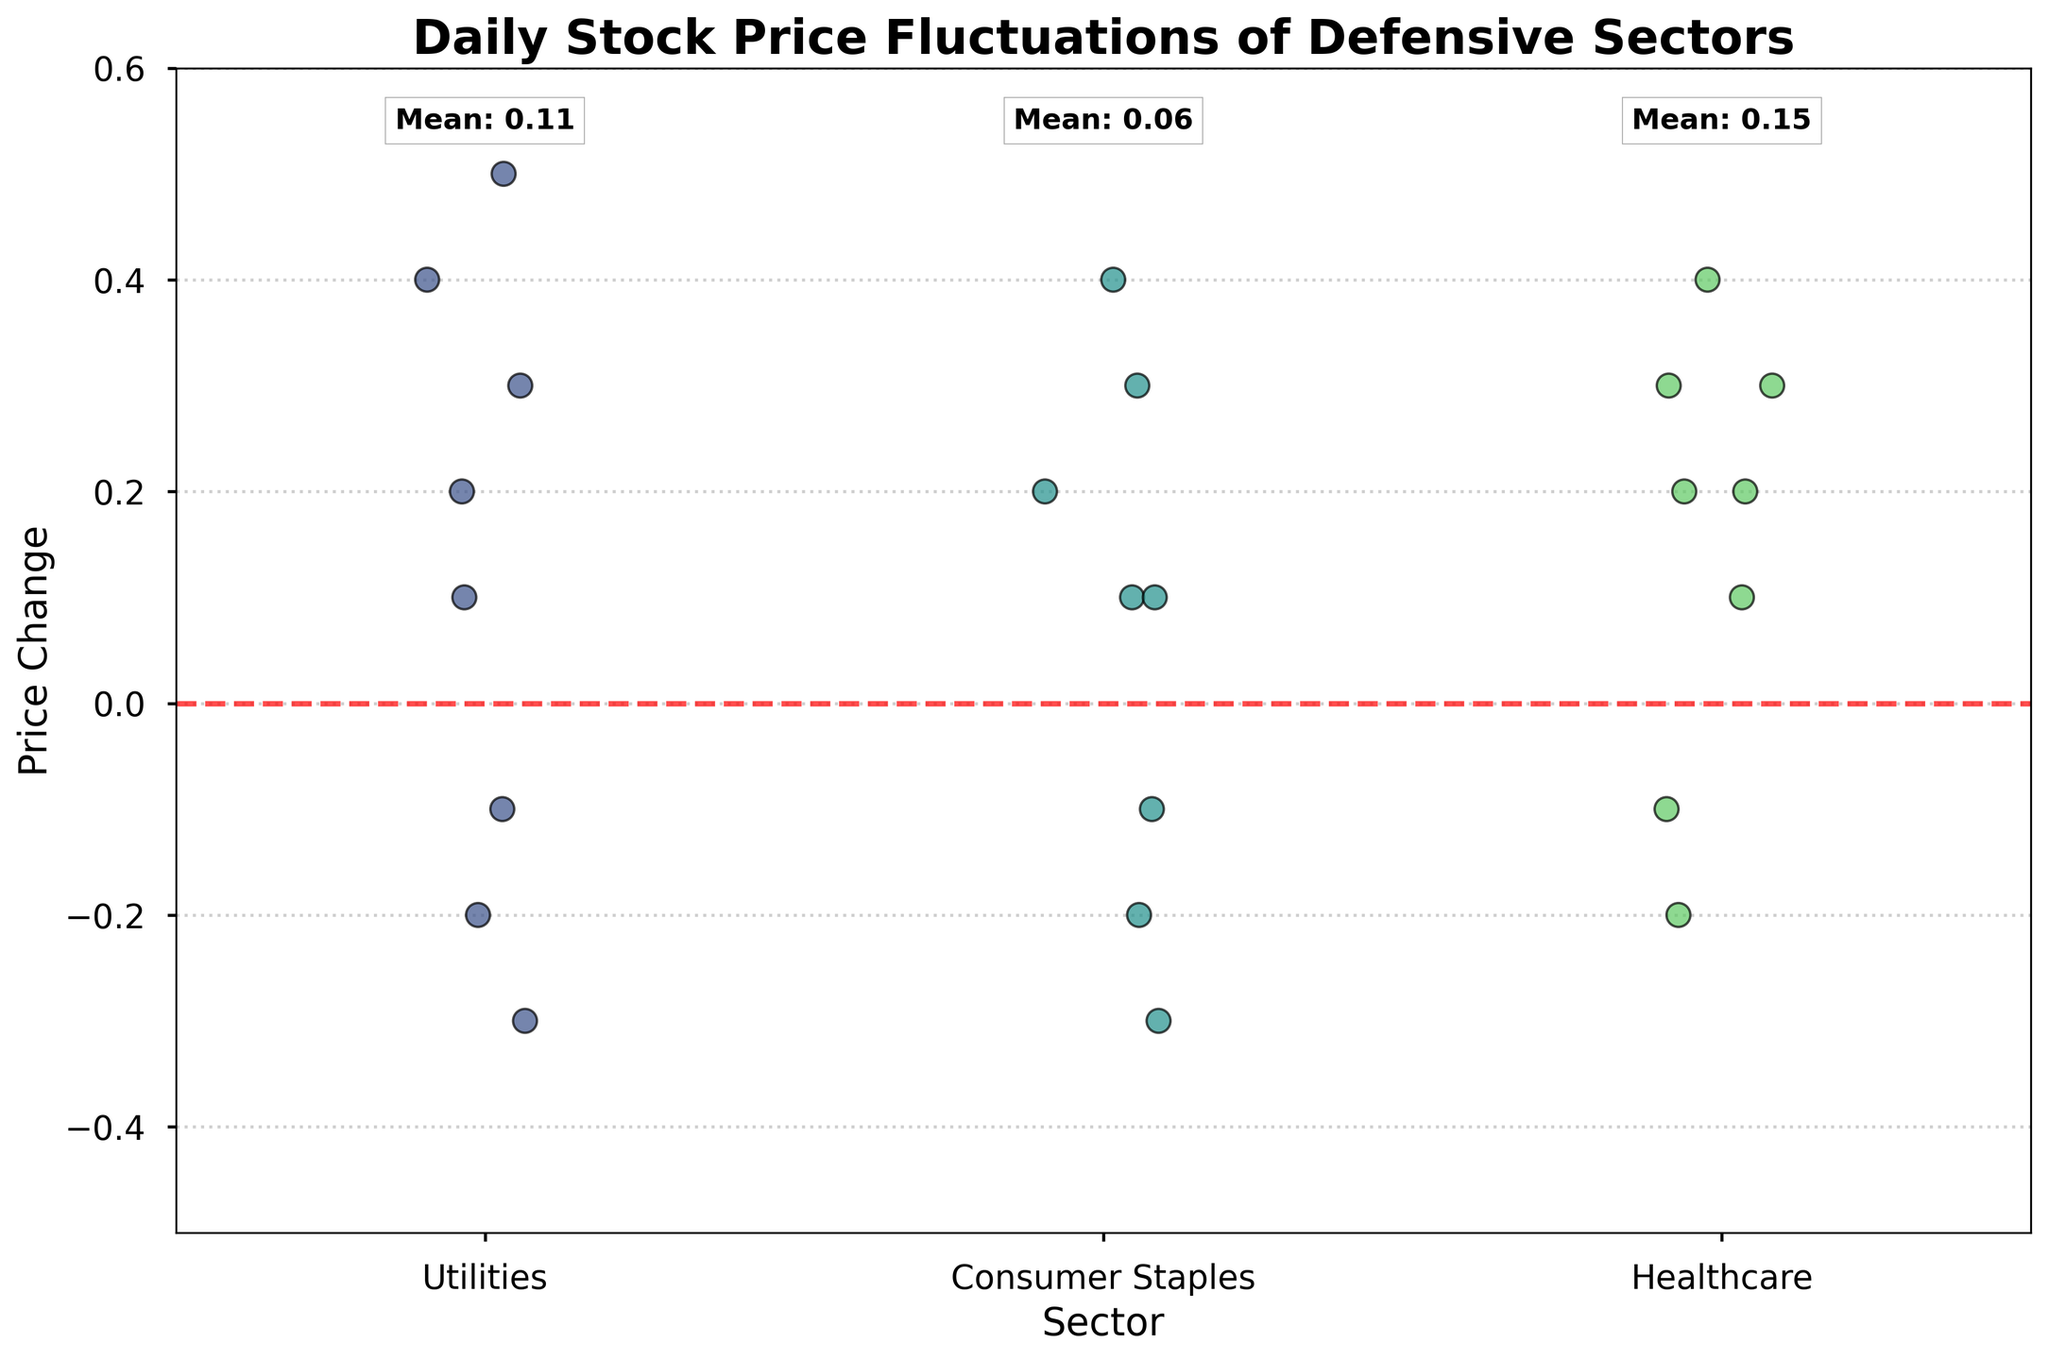What is the title of the figure? The title of the figure appears at the top in bold text. It states the topic or theme of the visualization.
Answer: Daily Stock Price Fluctuations of Defensive Sectors Which sector shows the highest mean price change? The memory aid text box near the top of each sector shows the mean price change. The sector with the highest value in this box has the highest mean price change.
Answer: Healthcare How does the Utilities sector's mean price change compare to the Consumer Staples sector? Examine the mean change values displayed near the top of each sector's strip. Calculate the difference between these values to understand the comparison.
Answer: Utilities have a higher mean price change than Consumer Staples How many sectors are compared in the figure? Count the distinct categories (distinct groups) plotted along the x-axis of the strip plot. Each category represents one sector.
Answer: 3 What is the range of the y-axis on the plot? The range is the span of the values on the y-axis, from the minimum to the maximum point. The minimum and maximum values are shown on the axis itself.
Answer: -0.5 to 0.6 Which sector has the most data points around a price change of 0.3? Look for the density of points plotted near the y-axis value of 0.3 for each sector. More points clustered in this region indicate the sector with most data points around that value.
Answer: Healthcare Which sector had the largest single daily price change? Identify the most extreme points (both positive and negative) in the strip plot. The point furthest from zero indicates the largest single daily price change.
Answer: Utilities What is the average daily price change for the Healthcare sector? The mean change value is provided in the text box near the top of the Healthcare category. Refer to this value directly.
Answer: 0.16 Which sector has the least variability in daily price changes? Observe the spread of the points for each sector. The sector with points closest to each other has the least variability.
Answer: Consumer Staples How many days did the Consumer Staples sector have a negative price change? Count the number of points below the horizontal line at y=0 in the Consumer Staples strip. Each point represents a day with a negative price change.
Answer: 3 